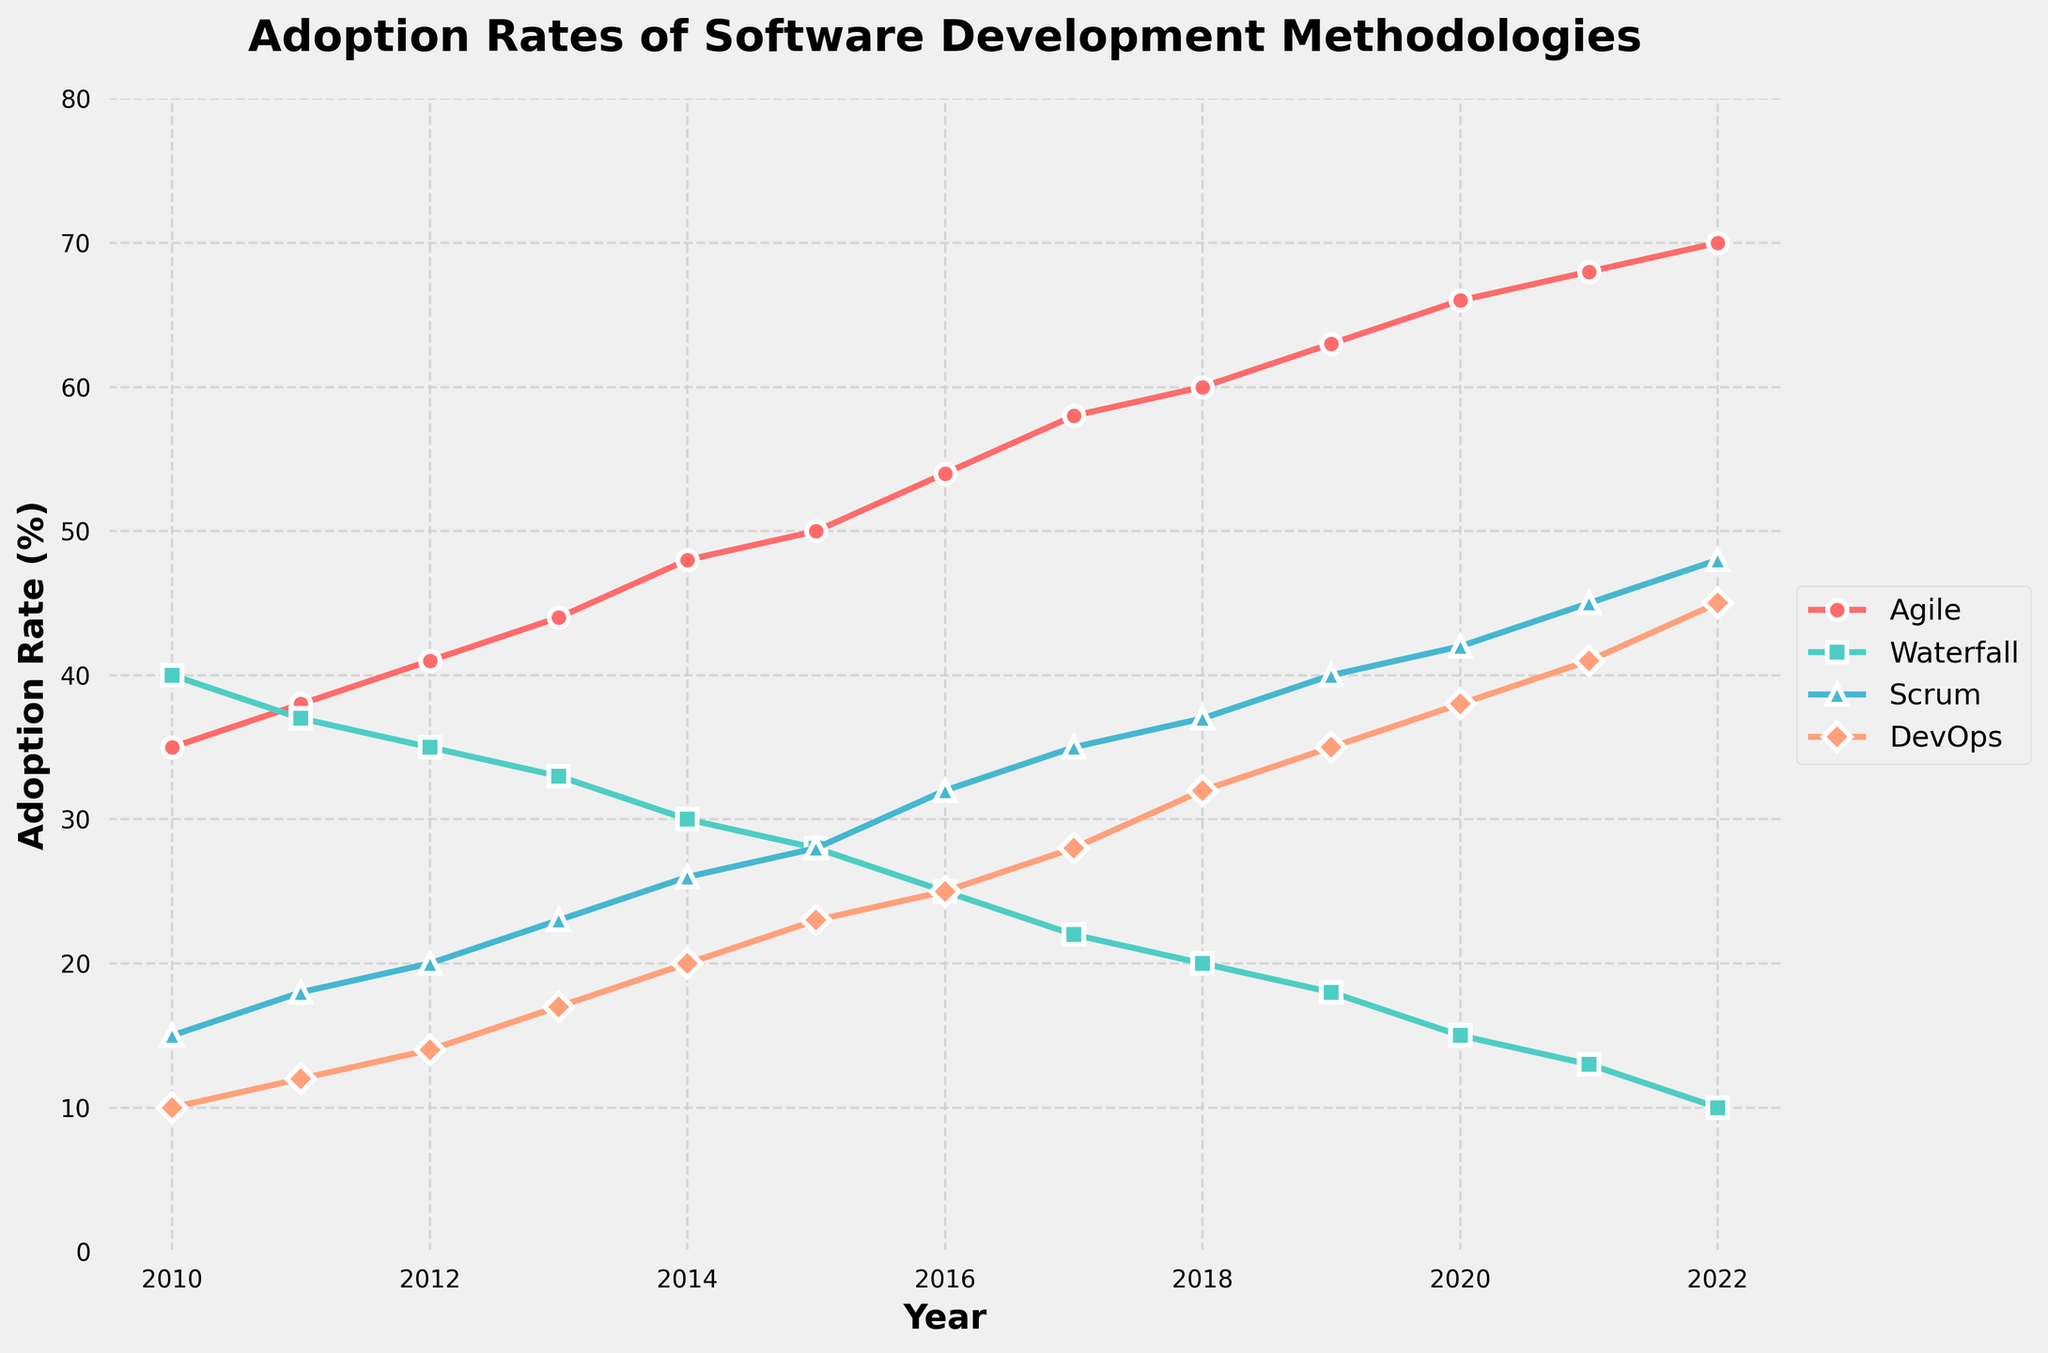What is the title of the figure? The title is located at the top of the figure and describes the main subject of the plot. The title is clearly written as "Adoption Rates of Software Development Methodologies".
Answer: Adoption Rates of Software Development Methodologies What year has the highest adoption rate for Agile? Look for the highest point on the Agile line and read the corresponding year on the x-axis. The highest point for Agile is at the year 2022.
Answer: 2022 Which methodology has the lowest adoption rate in 2014? Find the data points for all methodologies in 2014 and identify the lowest one. The lowest data point in 2014 is for DevOps with an adoption rate of 20%.
Answer: DevOps How does the adoption rate of Waterfall change from 2010 to 2022? Note the adoption rates for Waterfall in 2010 and 2022. The rate decreases from 40% in 2010 to 10% in 2022.
Answer: Decreases What is the average adoption rate of Scrum between 2010 and 2015? Add the Scrum adoption rates for each year from 2010 to 2015 and divide by the number of years (6). The average rate is (15+18+20+23+26+28)/6 = 21.67.
Answer: 21.67 Which methodology shows a consistent increase in adoption rate over time? Examine the trends of each methodology line from start to end. Both Agile and DevOps show consistent increases, but Agile has the most significant and uninterrupted growth.
Answer: Agile In what year do Agile and Waterfall have the same adoption rate? Identify the year where both lines intersect. Agile and Waterfall have the same adoption rate of 41% in 2012.
Answer: 2012 What is the difference in the adoption rate of DevOps between 2015 and 2020? Subtract the DevOps rate in 2015 from the rate in 2020. The difference is 38% - 23% = 15%.
Answer: 15% Which methodology experienced the most significant increase in adoption rates from 2010 to 2022? Compare the difference in adoption rates for all methodologies between 2010 and 2022. Agile experienced the most significant increase, from 35% to 70% (an increase of 35 percentage points).
Answer: Agile 